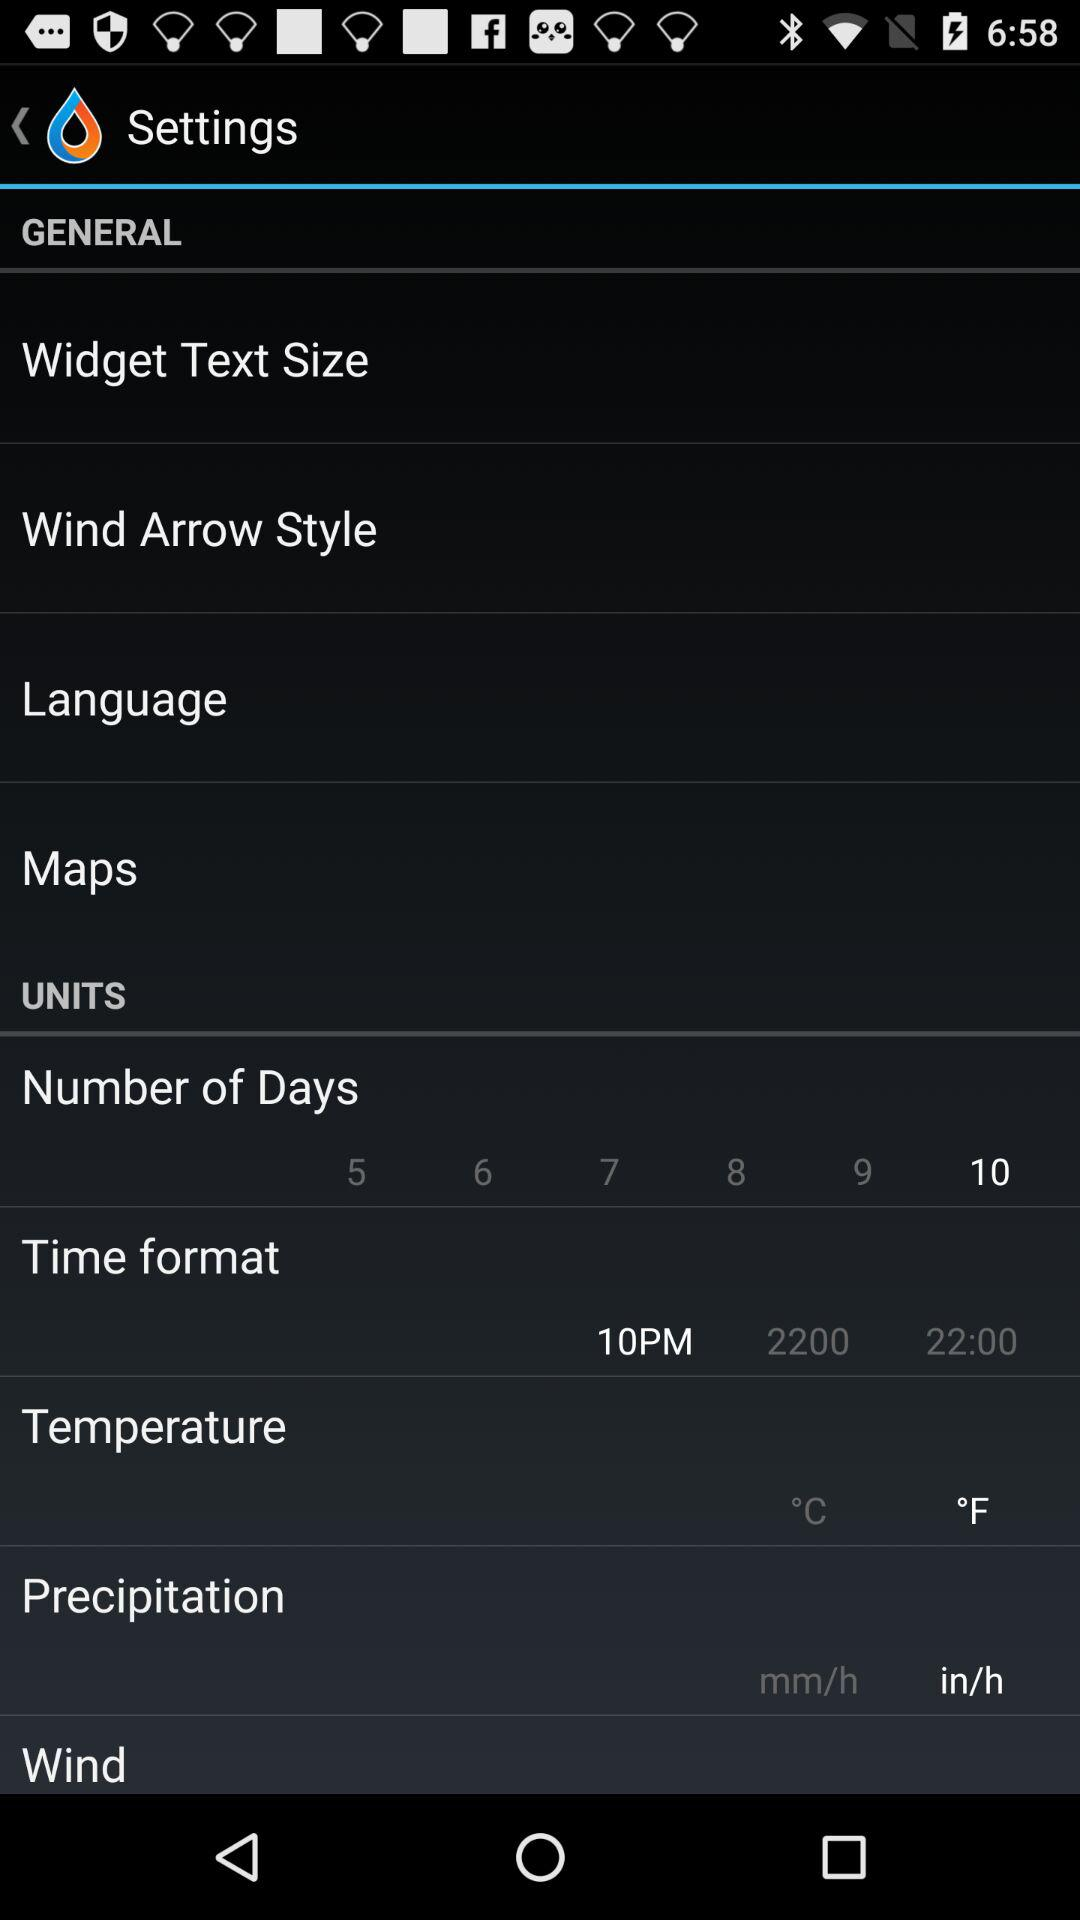Which time zone has been selected?
When the provided information is insufficient, respond with <no answer>. <no answer> 